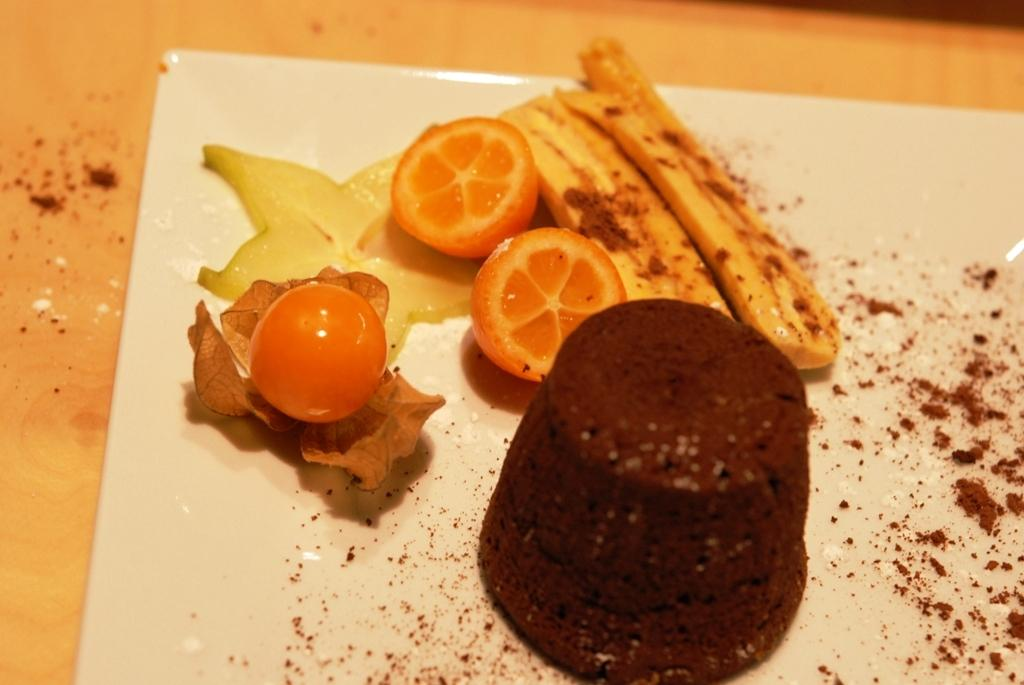What is on the serving plate in the image? The serving plate contains a cake and fruits. What else can be seen on the serving plate? There is a leaf and a powder sprinkled on the serving plate. What type of bed is visible in the image? There is no bed present in the image; it features a serving plate with a cake, fruits, leaf, and powder. 